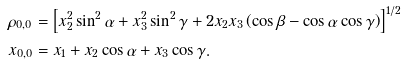Convert formula to latex. <formula><loc_0><loc_0><loc_500><loc_500>\rho _ { 0 , 0 } & = \left [ x _ { 2 } ^ { 2 } \sin ^ { 2 } \alpha + x _ { 3 } ^ { 2 } \sin ^ { 2 } \gamma + 2 x _ { 2 } x _ { 3 } \left ( \cos \beta - \cos \alpha \cos \gamma \right ) \right ] ^ { 1 / 2 } \\ x _ { 0 , 0 } & = x _ { 1 } + x _ { 2 } \cos \alpha + x _ { 3 } \cos \gamma .</formula> 